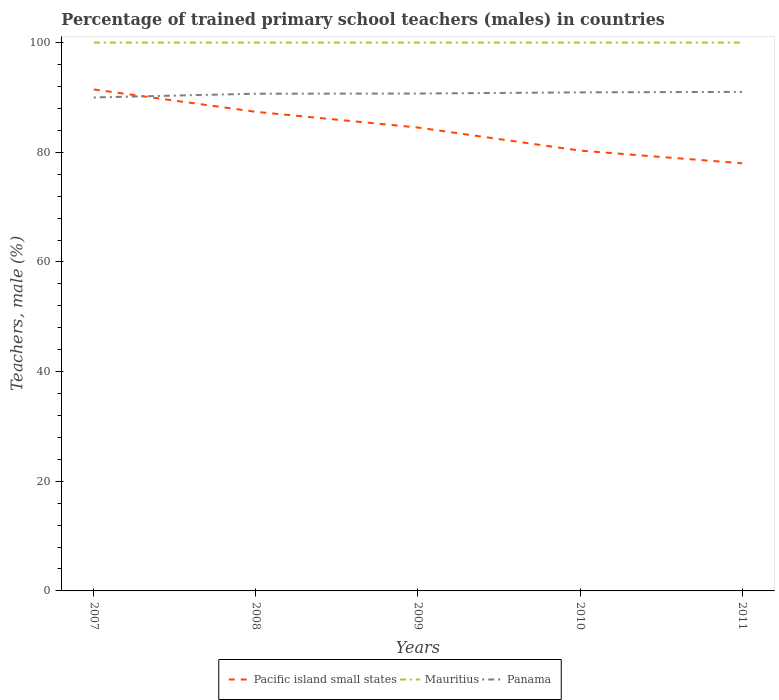Does the line corresponding to Mauritius intersect with the line corresponding to Pacific island small states?
Ensure brevity in your answer.  No. Across all years, what is the maximum percentage of trained primary school teachers (males) in Mauritius?
Your answer should be compact. 100. In which year was the percentage of trained primary school teachers (males) in Mauritius maximum?
Provide a succinct answer. 2007. What is the total percentage of trained primary school teachers (males) in Pacific island small states in the graph?
Provide a succinct answer. 13.46. What is the difference between the highest and the second highest percentage of trained primary school teachers (males) in Mauritius?
Your response must be concise. 0. What is the difference between the highest and the lowest percentage of trained primary school teachers (males) in Mauritius?
Provide a short and direct response. 0. How many lines are there?
Ensure brevity in your answer.  3. What is the difference between two consecutive major ticks on the Y-axis?
Your answer should be compact. 20. Does the graph contain any zero values?
Give a very brief answer. No. How many legend labels are there?
Ensure brevity in your answer.  3. How are the legend labels stacked?
Your answer should be compact. Horizontal. What is the title of the graph?
Your answer should be compact. Percentage of trained primary school teachers (males) in countries. What is the label or title of the Y-axis?
Offer a terse response. Teachers, male (%). What is the Teachers, male (%) in Pacific island small states in 2007?
Provide a succinct answer. 91.45. What is the Teachers, male (%) of Mauritius in 2007?
Make the answer very short. 100. What is the Teachers, male (%) in Panama in 2007?
Give a very brief answer. 90. What is the Teachers, male (%) in Pacific island small states in 2008?
Your answer should be compact. 87.37. What is the Teachers, male (%) of Mauritius in 2008?
Your answer should be compact. 100. What is the Teachers, male (%) in Panama in 2008?
Ensure brevity in your answer.  90.68. What is the Teachers, male (%) of Pacific island small states in 2009?
Ensure brevity in your answer.  84.51. What is the Teachers, male (%) in Panama in 2009?
Your response must be concise. 90.71. What is the Teachers, male (%) in Pacific island small states in 2010?
Your response must be concise. 80.3. What is the Teachers, male (%) of Mauritius in 2010?
Provide a succinct answer. 100. What is the Teachers, male (%) of Panama in 2010?
Make the answer very short. 90.92. What is the Teachers, male (%) in Pacific island small states in 2011?
Provide a short and direct response. 77.99. What is the Teachers, male (%) of Mauritius in 2011?
Ensure brevity in your answer.  100. What is the Teachers, male (%) of Panama in 2011?
Provide a succinct answer. 91.01. Across all years, what is the maximum Teachers, male (%) of Pacific island small states?
Your response must be concise. 91.45. Across all years, what is the maximum Teachers, male (%) in Mauritius?
Provide a succinct answer. 100. Across all years, what is the maximum Teachers, male (%) of Panama?
Offer a very short reply. 91.01. Across all years, what is the minimum Teachers, male (%) in Pacific island small states?
Your answer should be very brief. 77.99. Across all years, what is the minimum Teachers, male (%) in Panama?
Offer a terse response. 90. What is the total Teachers, male (%) of Pacific island small states in the graph?
Offer a terse response. 421.64. What is the total Teachers, male (%) in Panama in the graph?
Your response must be concise. 453.33. What is the difference between the Teachers, male (%) in Pacific island small states in 2007 and that in 2008?
Give a very brief answer. 4.08. What is the difference between the Teachers, male (%) in Mauritius in 2007 and that in 2008?
Ensure brevity in your answer.  0. What is the difference between the Teachers, male (%) in Panama in 2007 and that in 2008?
Provide a short and direct response. -0.69. What is the difference between the Teachers, male (%) in Pacific island small states in 2007 and that in 2009?
Ensure brevity in your answer.  6.94. What is the difference between the Teachers, male (%) of Panama in 2007 and that in 2009?
Offer a very short reply. -0.72. What is the difference between the Teachers, male (%) of Pacific island small states in 2007 and that in 2010?
Keep it short and to the point. 11.15. What is the difference between the Teachers, male (%) in Panama in 2007 and that in 2010?
Your response must be concise. -0.93. What is the difference between the Teachers, male (%) of Pacific island small states in 2007 and that in 2011?
Offer a terse response. 13.46. What is the difference between the Teachers, male (%) in Mauritius in 2007 and that in 2011?
Ensure brevity in your answer.  0. What is the difference between the Teachers, male (%) in Panama in 2007 and that in 2011?
Offer a very short reply. -1.02. What is the difference between the Teachers, male (%) in Pacific island small states in 2008 and that in 2009?
Your answer should be very brief. 2.86. What is the difference between the Teachers, male (%) of Mauritius in 2008 and that in 2009?
Provide a short and direct response. 0. What is the difference between the Teachers, male (%) of Panama in 2008 and that in 2009?
Keep it short and to the point. -0.03. What is the difference between the Teachers, male (%) of Pacific island small states in 2008 and that in 2010?
Your answer should be compact. 7.07. What is the difference between the Teachers, male (%) of Panama in 2008 and that in 2010?
Provide a short and direct response. -0.24. What is the difference between the Teachers, male (%) of Pacific island small states in 2008 and that in 2011?
Ensure brevity in your answer.  9.38. What is the difference between the Teachers, male (%) of Mauritius in 2008 and that in 2011?
Give a very brief answer. 0. What is the difference between the Teachers, male (%) in Panama in 2008 and that in 2011?
Your answer should be compact. -0.33. What is the difference between the Teachers, male (%) in Pacific island small states in 2009 and that in 2010?
Offer a terse response. 4.21. What is the difference between the Teachers, male (%) of Panama in 2009 and that in 2010?
Give a very brief answer. -0.21. What is the difference between the Teachers, male (%) of Pacific island small states in 2009 and that in 2011?
Provide a short and direct response. 6.52. What is the difference between the Teachers, male (%) in Mauritius in 2009 and that in 2011?
Your answer should be very brief. 0. What is the difference between the Teachers, male (%) of Panama in 2009 and that in 2011?
Offer a very short reply. -0.3. What is the difference between the Teachers, male (%) in Pacific island small states in 2010 and that in 2011?
Your answer should be compact. 2.31. What is the difference between the Teachers, male (%) of Panama in 2010 and that in 2011?
Provide a short and direct response. -0.09. What is the difference between the Teachers, male (%) of Pacific island small states in 2007 and the Teachers, male (%) of Mauritius in 2008?
Your answer should be very brief. -8.55. What is the difference between the Teachers, male (%) in Pacific island small states in 2007 and the Teachers, male (%) in Panama in 2008?
Offer a very short reply. 0.77. What is the difference between the Teachers, male (%) in Mauritius in 2007 and the Teachers, male (%) in Panama in 2008?
Provide a short and direct response. 9.32. What is the difference between the Teachers, male (%) of Pacific island small states in 2007 and the Teachers, male (%) of Mauritius in 2009?
Your response must be concise. -8.55. What is the difference between the Teachers, male (%) of Pacific island small states in 2007 and the Teachers, male (%) of Panama in 2009?
Provide a short and direct response. 0.74. What is the difference between the Teachers, male (%) of Mauritius in 2007 and the Teachers, male (%) of Panama in 2009?
Make the answer very short. 9.29. What is the difference between the Teachers, male (%) of Pacific island small states in 2007 and the Teachers, male (%) of Mauritius in 2010?
Provide a short and direct response. -8.55. What is the difference between the Teachers, male (%) in Pacific island small states in 2007 and the Teachers, male (%) in Panama in 2010?
Provide a short and direct response. 0.53. What is the difference between the Teachers, male (%) of Mauritius in 2007 and the Teachers, male (%) of Panama in 2010?
Ensure brevity in your answer.  9.08. What is the difference between the Teachers, male (%) of Pacific island small states in 2007 and the Teachers, male (%) of Mauritius in 2011?
Your response must be concise. -8.55. What is the difference between the Teachers, male (%) of Pacific island small states in 2007 and the Teachers, male (%) of Panama in 2011?
Provide a succinct answer. 0.44. What is the difference between the Teachers, male (%) in Mauritius in 2007 and the Teachers, male (%) in Panama in 2011?
Your answer should be very brief. 8.99. What is the difference between the Teachers, male (%) in Pacific island small states in 2008 and the Teachers, male (%) in Mauritius in 2009?
Your response must be concise. -12.63. What is the difference between the Teachers, male (%) of Pacific island small states in 2008 and the Teachers, male (%) of Panama in 2009?
Keep it short and to the point. -3.34. What is the difference between the Teachers, male (%) in Mauritius in 2008 and the Teachers, male (%) in Panama in 2009?
Offer a terse response. 9.29. What is the difference between the Teachers, male (%) in Pacific island small states in 2008 and the Teachers, male (%) in Mauritius in 2010?
Provide a succinct answer. -12.63. What is the difference between the Teachers, male (%) of Pacific island small states in 2008 and the Teachers, male (%) of Panama in 2010?
Your response must be concise. -3.55. What is the difference between the Teachers, male (%) of Mauritius in 2008 and the Teachers, male (%) of Panama in 2010?
Your answer should be very brief. 9.08. What is the difference between the Teachers, male (%) of Pacific island small states in 2008 and the Teachers, male (%) of Mauritius in 2011?
Keep it short and to the point. -12.63. What is the difference between the Teachers, male (%) of Pacific island small states in 2008 and the Teachers, male (%) of Panama in 2011?
Make the answer very short. -3.64. What is the difference between the Teachers, male (%) of Mauritius in 2008 and the Teachers, male (%) of Panama in 2011?
Give a very brief answer. 8.99. What is the difference between the Teachers, male (%) of Pacific island small states in 2009 and the Teachers, male (%) of Mauritius in 2010?
Provide a short and direct response. -15.49. What is the difference between the Teachers, male (%) in Pacific island small states in 2009 and the Teachers, male (%) in Panama in 2010?
Provide a short and direct response. -6.41. What is the difference between the Teachers, male (%) in Mauritius in 2009 and the Teachers, male (%) in Panama in 2010?
Your answer should be compact. 9.08. What is the difference between the Teachers, male (%) in Pacific island small states in 2009 and the Teachers, male (%) in Mauritius in 2011?
Offer a terse response. -15.49. What is the difference between the Teachers, male (%) of Pacific island small states in 2009 and the Teachers, male (%) of Panama in 2011?
Make the answer very short. -6.5. What is the difference between the Teachers, male (%) in Mauritius in 2009 and the Teachers, male (%) in Panama in 2011?
Provide a succinct answer. 8.99. What is the difference between the Teachers, male (%) of Pacific island small states in 2010 and the Teachers, male (%) of Mauritius in 2011?
Keep it short and to the point. -19.7. What is the difference between the Teachers, male (%) of Pacific island small states in 2010 and the Teachers, male (%) of Panama in 2011?
Offer a terse response. -10.71. What is the difference between the Teachers, male (%) of Mauritius in 2010 and the Teachers, male (%) of Panama in 2011?
Provide a short and direct response. 8.99. What is the average Teachers, male (%) of Pacific island small states per year?
Your response must be concise. 84.33. What is the average Teachers, male (%) in Mauritius per year?
Make the answer very short. 100. What is the average Teachers, male (%) in Panama per year?
Give a very brief answer. 90.67. In the year 2007, what is the difference between the Teachers, male (%) in Pacific island small states and Teachers, male (%) in Mauritius?
Provide a succinct answer. -8.55. In the year 2007, what is the difference between the Teachers, male (%) of Pacific island small states and Teachers, male (%) of Panama?
Provide a succinct answer. 1.46. In the year 2007, what is the difference between the Teachers, male (%) in Mauritius and Teachers, male (%) in Panama?
Provide a short and direct response. 10. In the year 2008, what is the difference between the Teachers, male (%) of Pacific island small states and Teachers, male (%) of Mauritius?
Offer a terse response. -12.63. In the year 2008, what is the difference between the Teachers, male (%) of Pacific island small states and Teachers, male (%) of Panama?
Offer a very short reply. -3.31. In the year 2008, what is the difference between the Teachers, male (%) in Mauritius and Teachers, male (%) in Panama?
Make the answer very short. 9.32. In the year 2009, what is the difference between the Teachers, male (%) in Pacific island small states and Teachers, male (%) in Mauritius?
Provide a short and direct response. -15.49. In the year 2009, what is the difference between the Teachers, male (%) in Pacific island small states and Teachers, male (%) in Panama?
Your answer should be very brief. -6.2. In the year 2009, what is the difference between the Teachers, male (%) of Mauritius and Teachers, male (%) of Panama?
Your response must be concise. 9.29. In the year 2010, what is the difference between the Teachers, male (%) of Pacific island small states and Teachers, male (%) of Mauritius?
Provide a short and direct response. -19.7. In the year 2010, what is the difference between the Teachers, male (%) of Pacific island small states and Teachers, male (%) of Panama?
Keep it short and to the point. -10.62. In the year 2010, what is the difference between the Teachers, male (%) of Mauritius and Teachers, male (%) of Panama?
Offer a terse response. 9.08. In the year 2011, what is the difference between the Teachers, male (%) of Pacific island small states and Teachers, male (%) of Mauritius?
Offer a very short reply. -22.01. In the year 2011, what is the difference between the Teachers, male (%) in Pacific island small states and Teachers, male (%) in Panama?
Make the answer very short. -13.02. In the year 2011, what is the difference between the Teachers, male (%) of Mauritius and Teachers, male (%) of Panama?
Give a very brief answer. 8.99. What is the ratio of the Teachers, male (%) in Pacific island small states in 2007 to that in 2008?
Offer a terse response. 1.05. What is the ratio of the Teachers, male (%) in Mauritius in 2007 to that in 2008?
Provide a short and direct response. 1. What is the ratio of the Teachers, male (%) of Pacific island small states in 2007 to that in 2009?
Provide a short and direct response. 1.08. What is the ratio of the Teachers, male (%) of Mauritius in 2007 to that in 2009?
Your response must be concise. 1. What is the ratio of the Teachers, male (%) of Pacific island small states in 2007 to that in 2010?
Provide a short and direct response. 1.14. What is the ratio of the Teachers, male (%) in Pacific island small states in 2007 to that in 2011?
Your answer should be compact. 1.17. What is the ratio of the Teachers, male (%) in Mauritius in 2007 to that in 2011?
Provide a succinct answer. 1. What is the ratio of the Teachers, male (%) in Pacific island small states in 2008 to that in 2009?
Your answer should be compact. 1.03. What is the ratio of the Teachers, male (%) in Panama in 2008 to that in 2009?
Ensure brevity in your answer.  1. What is the ratio of the Teachers, male (%) of Pacific island small states in 2008 to that in 2010?
Offer a terse response. 1.09. What is the ratio of the Teachers, male (%) of Mauritius in 2008 to that in 2010?
Keep it short and to the point. 1. What is the ratio of the Teachers, male (%) in Panama in 2008 to that in 2010?
Your response must be concise. 1. What is the ratio of the Teachers, male (%) of Pacific island small states in 2008 to that in 2011?
Your answer should be compact. 1.12. What is the ratio of the Teachers, male (%) of Panama in 2008 to that in 2011?
Your answer should be very brief. 1. What is the ratio of the Teachers, male (%) in Pacific island small states in 2009 to that in 2010?
Offer a terse response. 1.05. What is the ratio of the Teachers, male (%) in Mauritius in 2009 to that in 2010?
Your response must be concise. 1. What is the ratio of the Teachers, male (%) in Pacific island small states in 2009 to that in 2011?
Offer a terse response. 1.08. What is the ratio of the Teachers, male (%) of Pacific island small states in 2010 to that in 2011?
Offer a terse response. 1.03. What is the ratio of the Teachers, male (%) in Mauritius in 2010 to that in 2011?
Your response must be concise. 1. What is the difference between the highest and the second highest Teachers, male (%) in Pacific island small states?
Provide a succinct answer. 4.08. What is the difference between the highest and the second highest Teachers, male (%) of Panama?
Provide a short and direct response. 0.09. What is the difference between the highest and the lowest Teachers, male (%) in Pacific island small states?
Offer a terse response. 13.46. What is the difference between the highest and the lowest Teachers, male (%) of Panama?
Ensure brevity in your answer.  1.02. 